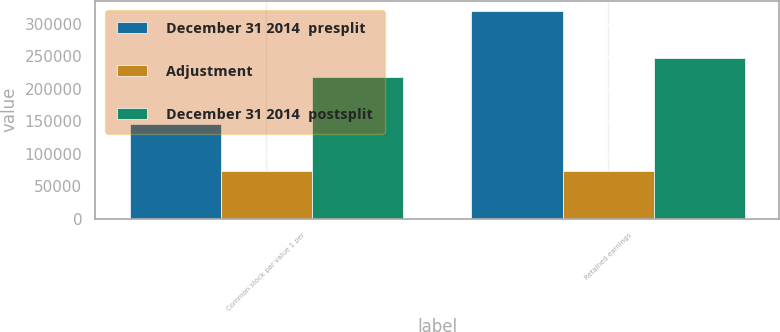<chart> <loc_0><loc_0><loc_500><loc_500><stacked_bar_chart><ecel><fcel>Common stock par value 1 per<fcel>Retained earnings<nl><fcel>December 31 2014  presplit<fcel>145722<fcel>319803<nl><fcel>Adjustment<fcel>72761<fcel>72761<nl><fcel>December 31 2014  postsplit<fcel>218483<fcel>247042<nl></chart> 